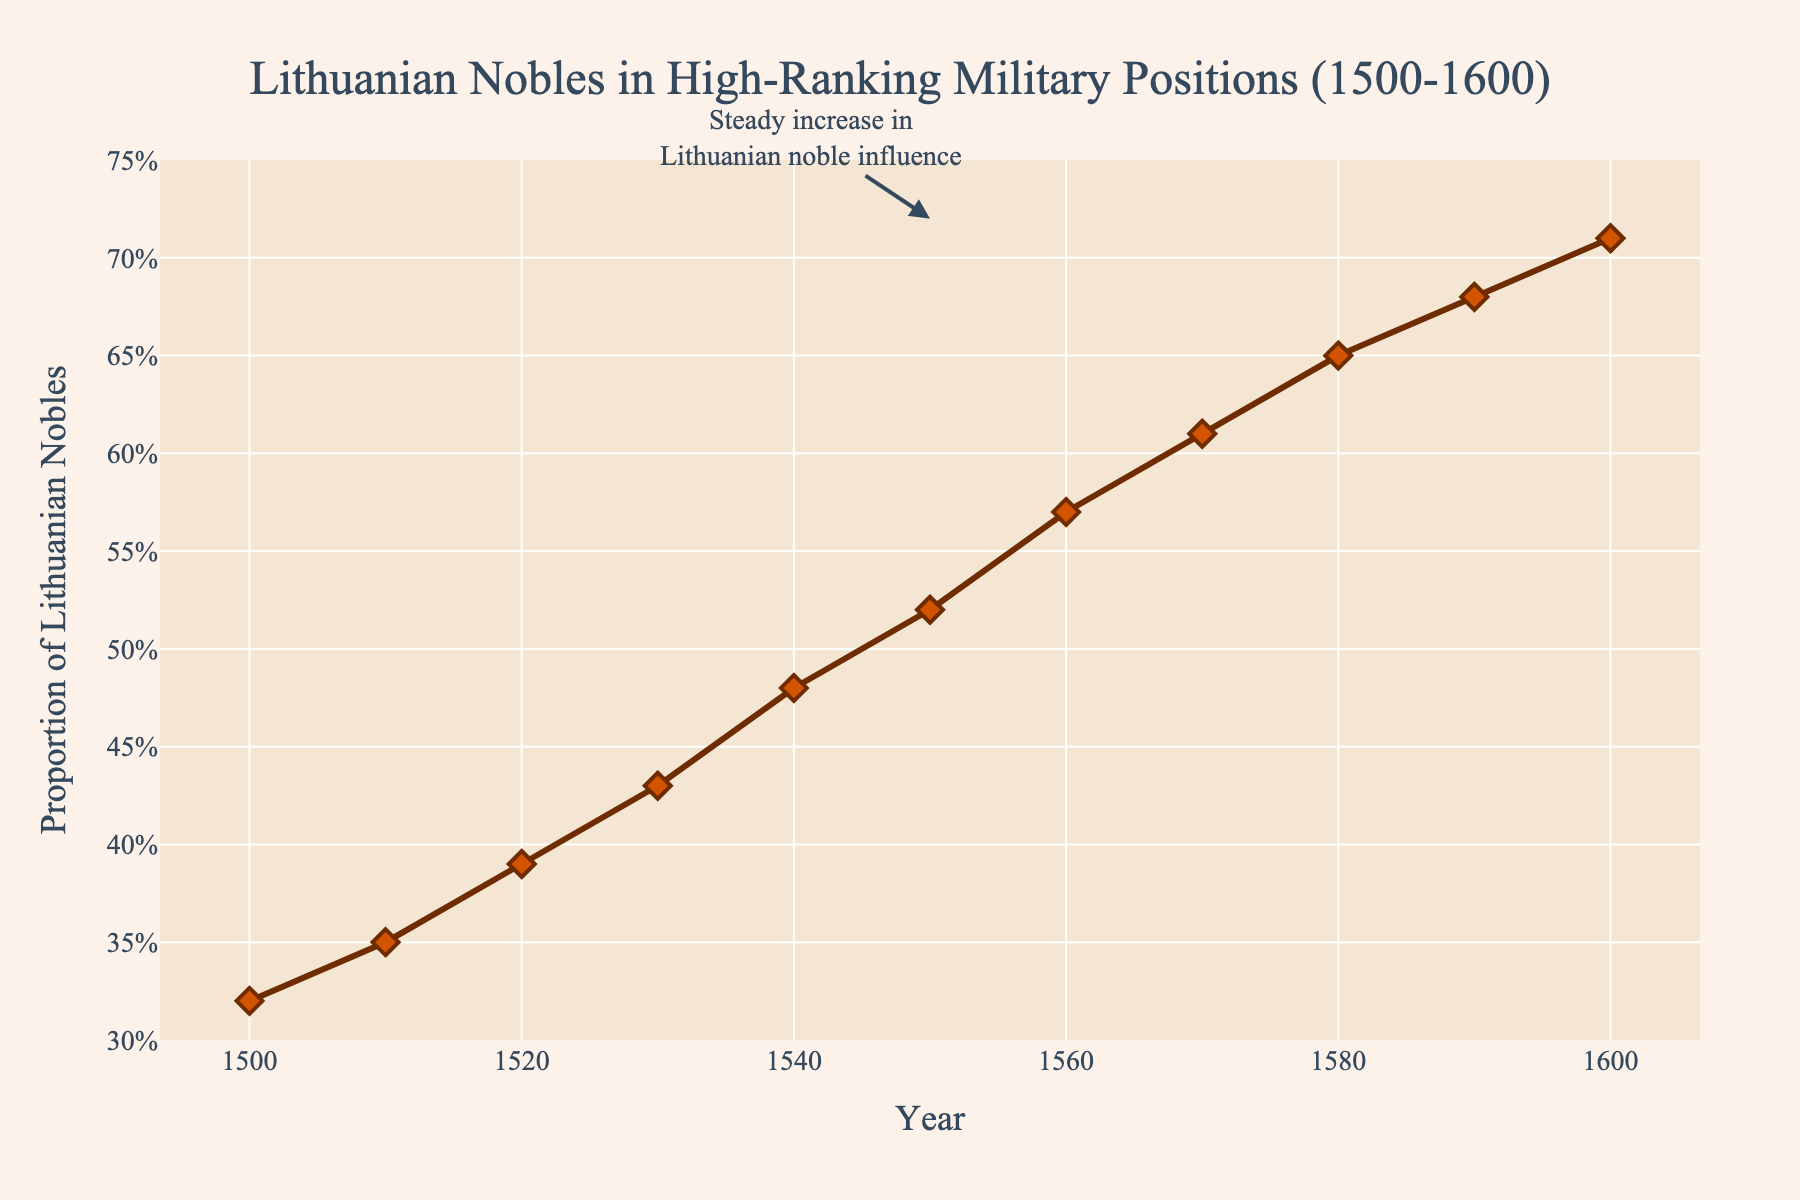what trend is observed in the proportion of Lithuanian nobles in high-ranking military positions from 1500 to 1600? From the line chart, it is clear that the proportion of Lithuanian nobles in high-ranking military positions consistently increased from 0.32 in 1500 to 0.71 in 1600. This indicates a steady upward trend over the century.
Answer: Consistent increase What is the difference in the proportion of Lithuanian nobles in high-ranking military positions between 1500 and 1600? Referring to the chart, the proportion in 1500 was 0.32, and in 1600 it was 0.71. Subtracting the earlier proportion from the later one gives 0.71 - 0.32 = 0.39.
Answer: 0.39 In which decade did the proportion of Lithuanian nobles first reach above 0.5? The line chart shows that the proportion first exceeded 0.5 in the 1550s, where it was recorded as 0.52.
Answer: 1550s How does the proportion of Lithuanian nobles in high-ranking military positions in 1540 compare to that in 1560? The chart shows that the proportion in 1540 was 0.48, and in 1560 it was 0.57. Comparing these values: 0.57 (1560) is greater than 0.48 (1540).
Answer: Greater in 1560 What was the increase in the proportion of Lithuanian nobles holding high-ranking military positions from 1530 to 1540? The proportion in 1530 was 0.43, and in 1540 it was 0.48. The increase is calculated as 0.48 - 0.43 = 0.05.
Answer: 0.05 What's the average proportion of Lithuanian nobles in high-ranking military positions across all the recorded years? Summing all the proportions from 1500 to 1600: 0.32+0.35+0.39+0.43+0.48+0.52+0.57+0.61+0.65+0.68+0.71 = 5.71. Dividing this by the number of years (11): 5.71 / 11 ≈ 0.52.
Answer: ~0.52 Is there any annotation in the chart indicating a particular insight? If so, where is it located? The chart contains an annotation around the year 1550 that mentions "Steady increase in Lithuanian noble influence," indicating a notable historical trend observed in the chart.
Answer: Yes, around 1550 What is the lowest recorded proportion of Lithuanian nobles in high-ranking military positions during the 16th century, and in which year did it occur? The lowest recorded proportion in the data is 0.32, which occurred in the year 1500 according to the line chart.
Answer: 0.32 in 1500 